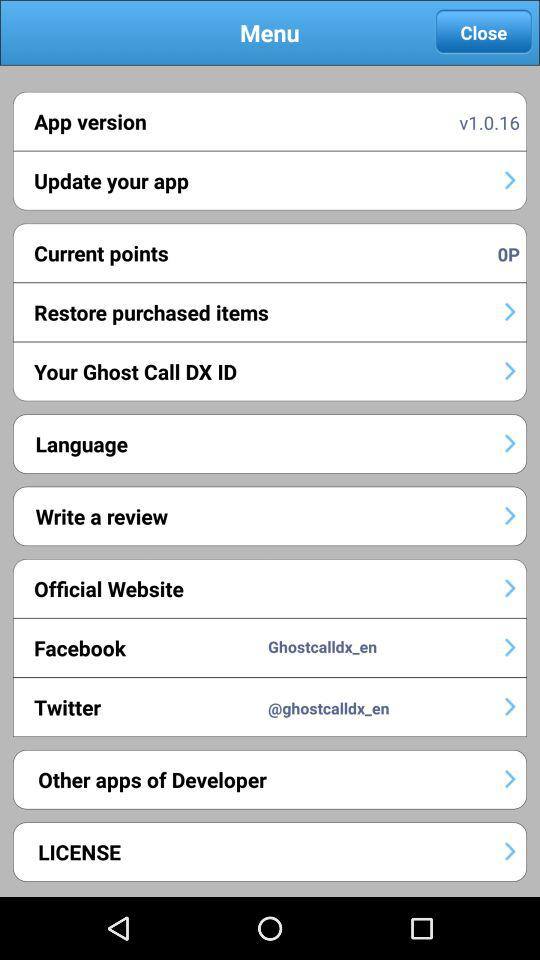What is the app version? The version is v1.0.16. 